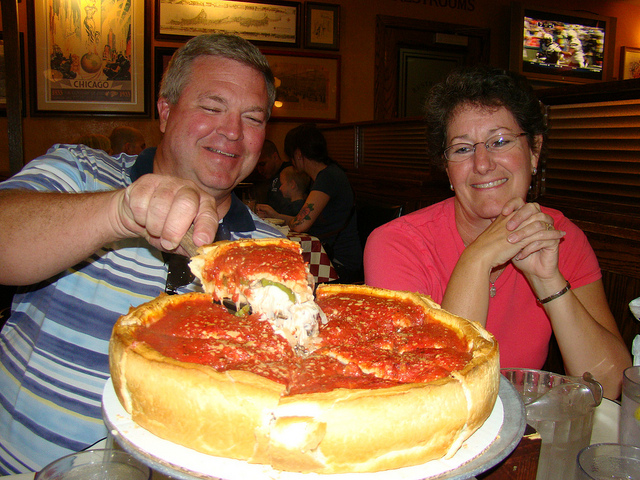<image>What utensil is on the table? It is ambiguous what utensil is on the table. It can be a knife or a fork. What utensil is on the table? I am not sure what utensil is on the table. It can be seen 'knife', 'fork', 'pie server' or 'pie knife'. 